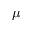<formula> <loc_0><loc_0><loc_500><loc_500>\mu</formula> 